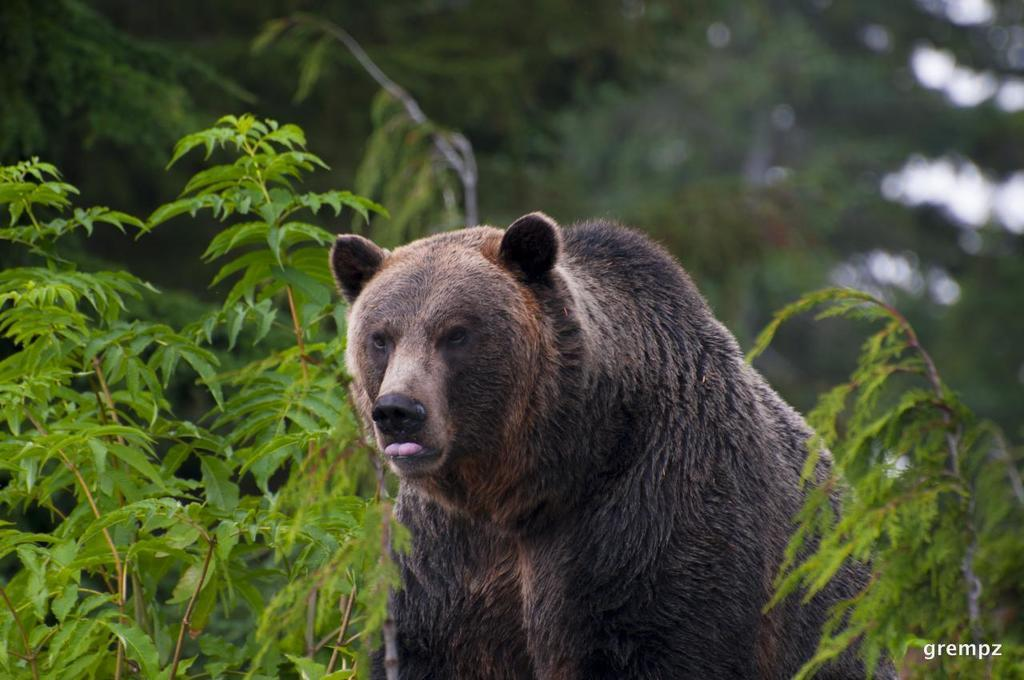What animal is present in the image? There is a bear in the image. What is the bear doing in the image? The bear is standing on a plant. What can be seen in the background of the image? There are trees in the background of the image. What type of whip is the bear using to perform magic tricks in the image? There is no whip or magic tricks present in the image; it features a bear standing on a plant with trees in the background. 